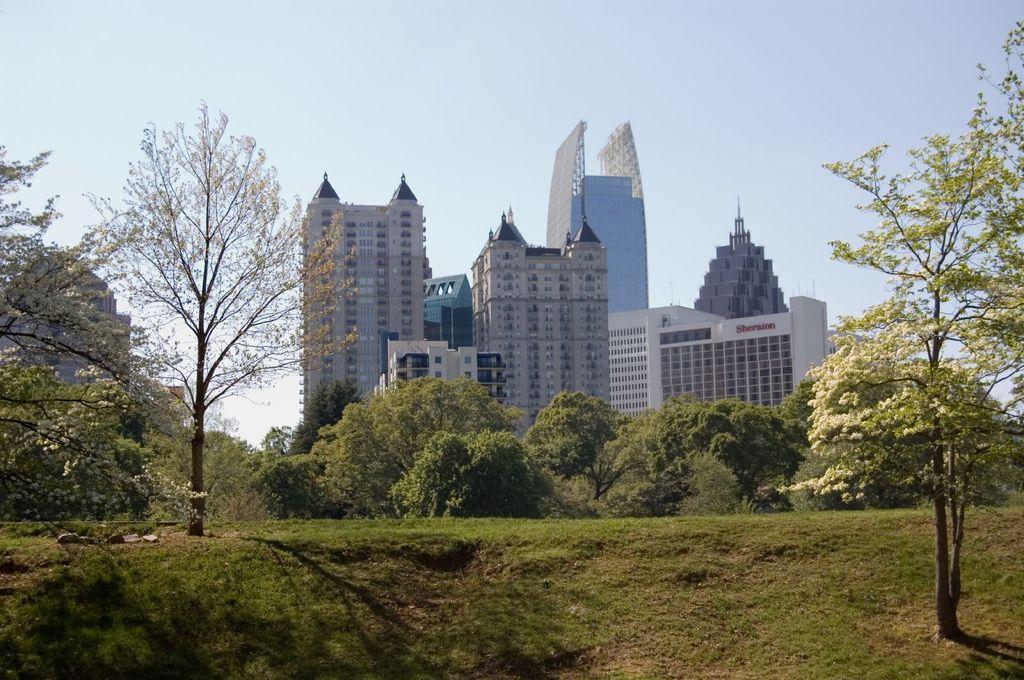Could you give a brief overview of what you see in this image? In this image we can see some grass, there are some trees and in the background of the image there are some buildings and top of the image there is clear sky. 